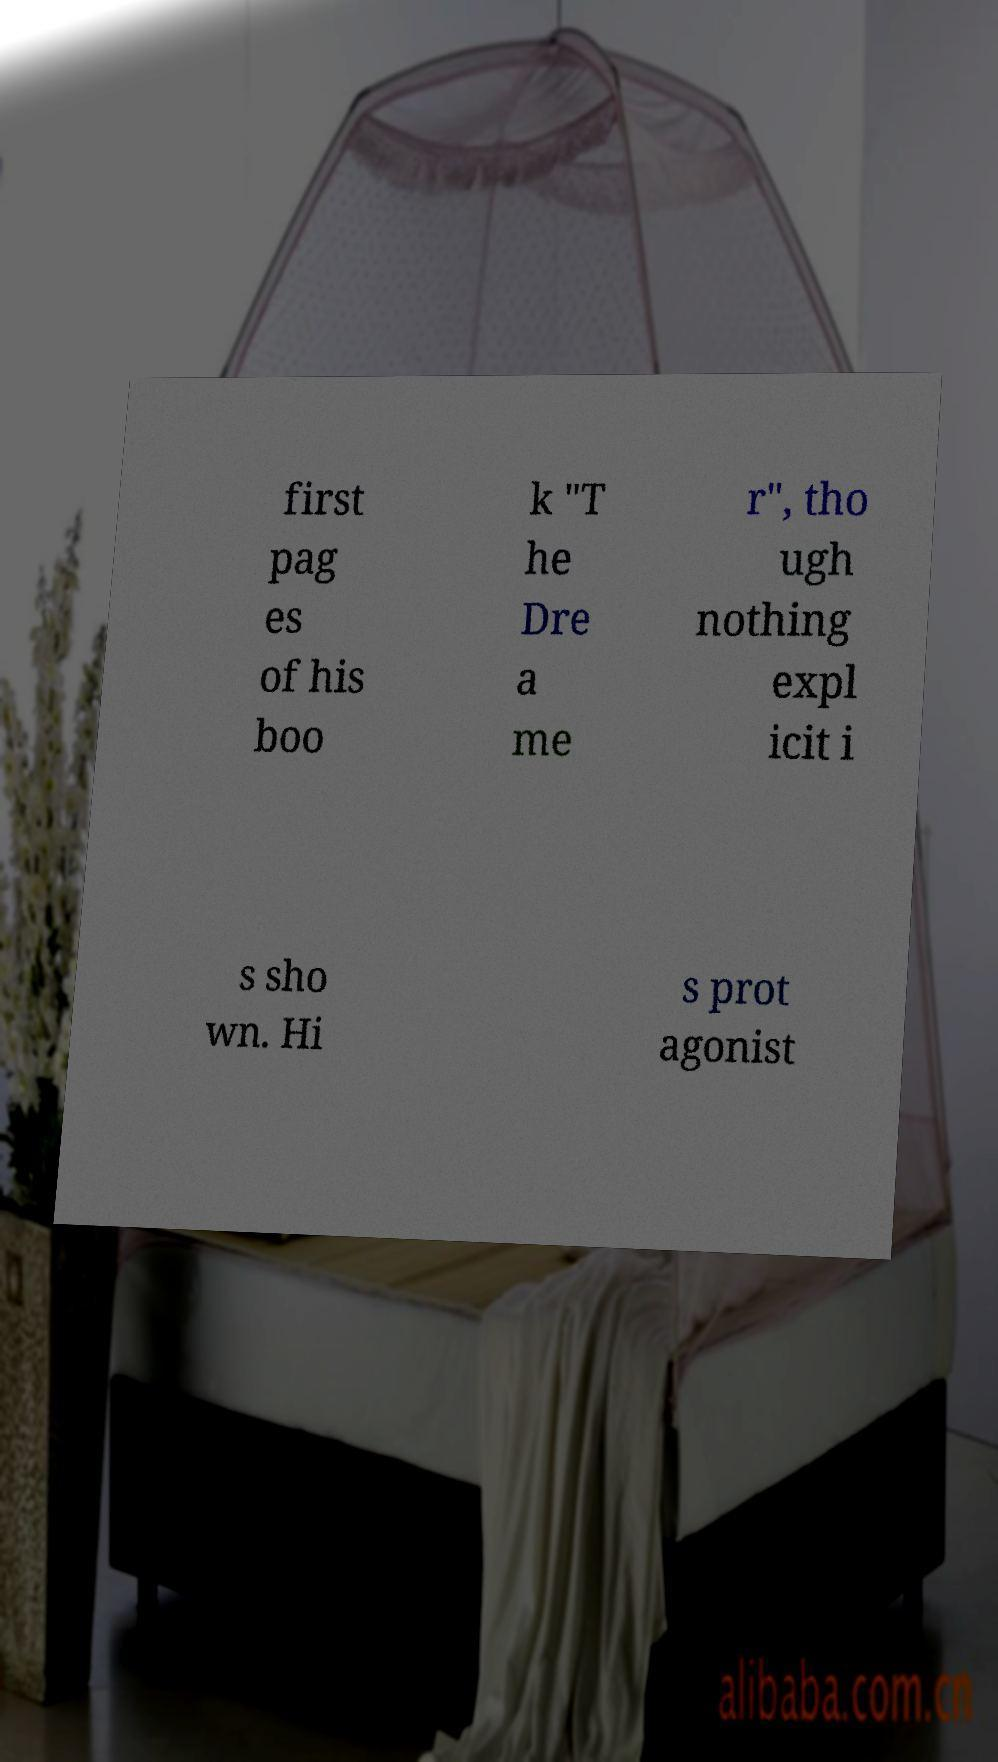Can you read and provide the text displayed in the image?This photo seems to have some interesting text. Can you extract and type it out for me? first pag es of his boo k "T he Dre a me r", tho ugh nothing expl icit i s sho wn. Hi s prot agonist 